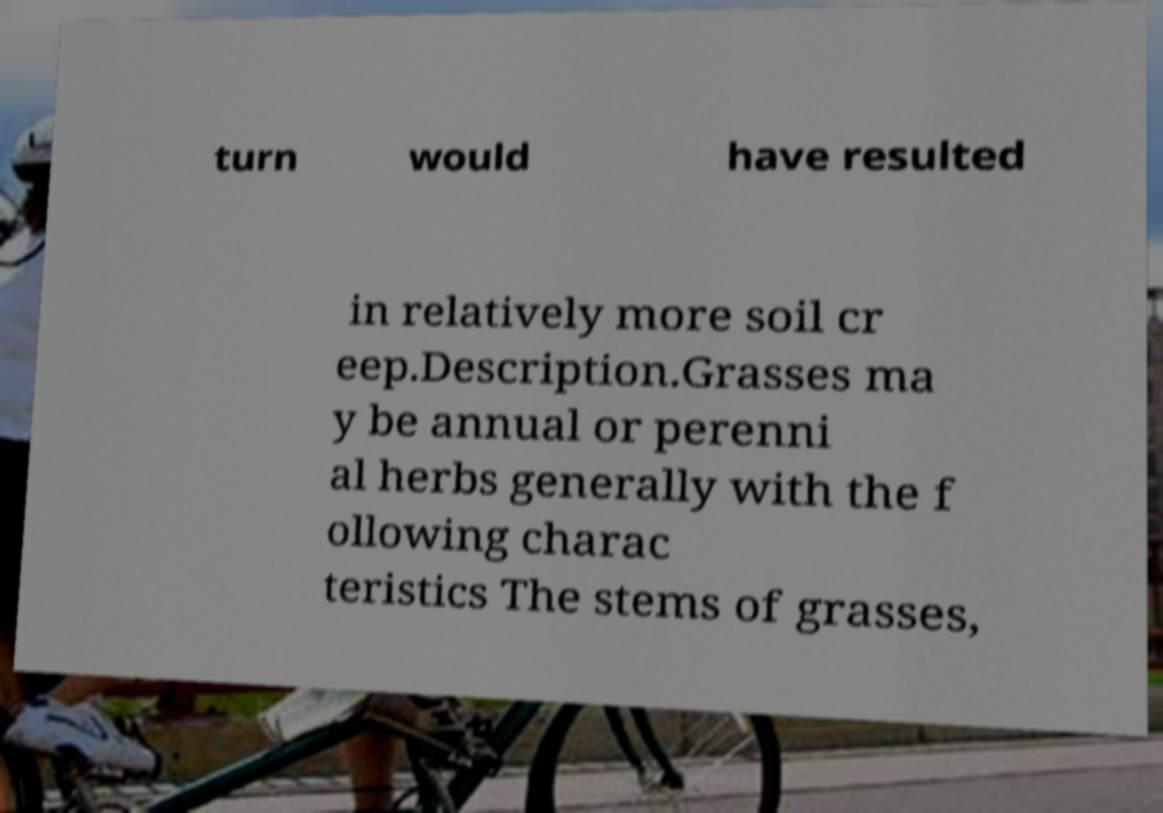Could you assist in decoding the text presented in this image and type it out clearly? turn would have resulted in relatively more soil cr eep.Description.Grasses ma y be annual or perenni al herbs generally with the f ollowing charac teristics The stems of grasses, 